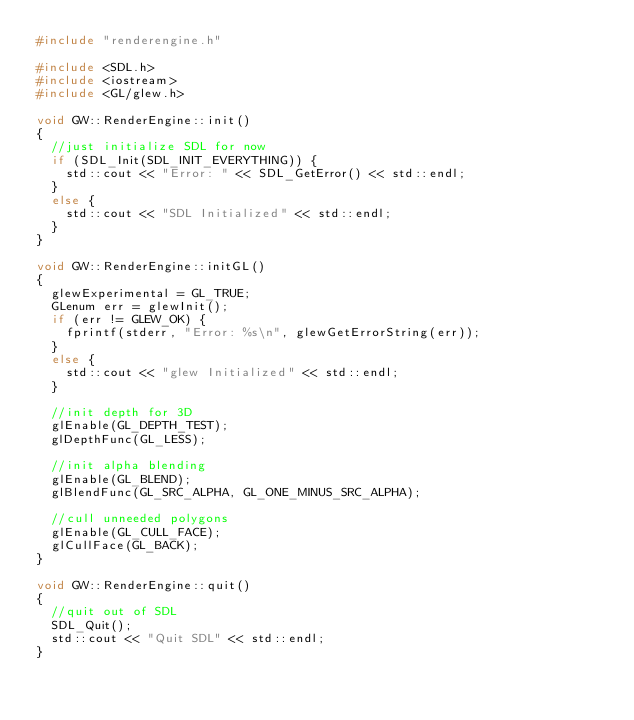<code> <loc_0><loc_0><loc_500><loc_500><_C++_>#include "renderengine.h"

#include <SDL.h>
#include <iostream>
#include <GL/glew.h>

void GW::RenderEngine::init()
{
	//just initialize SDL for now
	if (SDL_Init(SDL_INIT_EVERYTHING)) {
		std::cout << "Error: " << SDL_GetError() << std::endl;
	}
	else {
		std::cout << "SDL Initialized" << std::endl;
	}
}

void GW::RenderEngine::initGL()
{
	glewExperimental = GL_TRUE;
	GLenum err = glewInit();
	if (err != GLEW_OK) {
		fprintf(stderr, "Error: %s\n", glewGetErrorString(err));
	}
	else {
		std::cout << "glew Initialized" << std::endl;
	}

	//init depth for 3D
	glEnable(GL_DEPTH_TEST);
	glDepthFunc(GL_LESS);

	//init alpha blending
	glEnable(GL_BLEND);
	glBlendFunc(GL_SRC_ALPHA, GL_ONE_MINUS_SRC_ALPHA);

	//cull unneeded polygons
	glEnable(GL_CULL_FACE);
	glCullFace(GL_BACK);
}

void GW::RenderEngine::quit()
{
	//quit out of SDL
	SDL_Quit();
	std::cout << "Quit SDL" << std::endl;
}</code> 